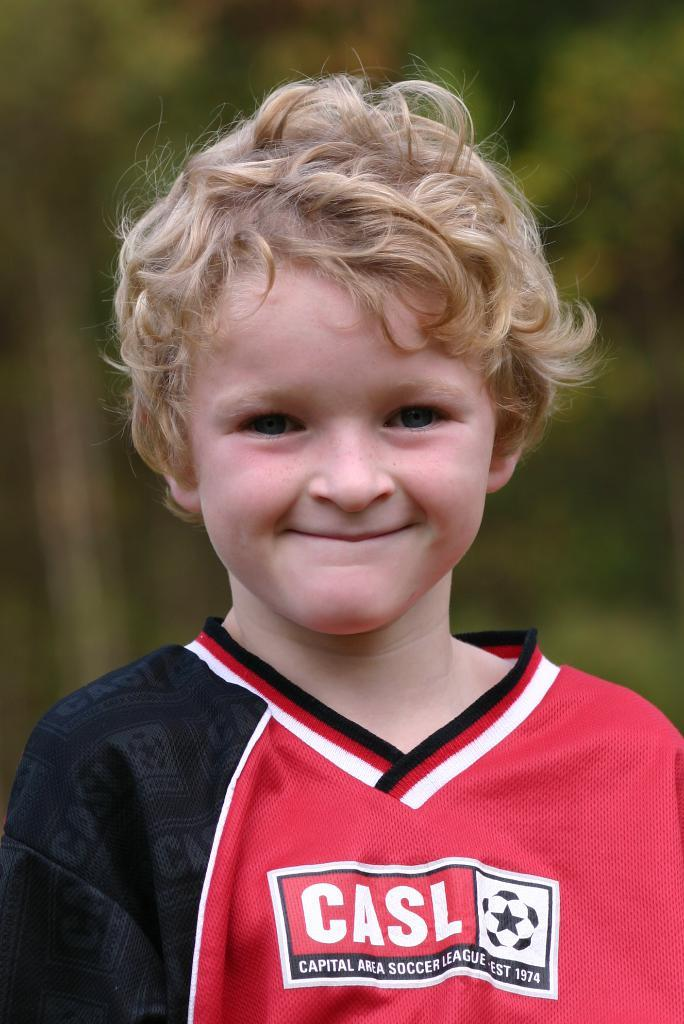<image>
Share a concise interpretation of the image provided. A boy wears a red and black jersey with the text "CASL" on the front. 